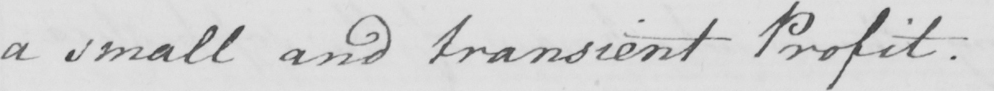What text is written in this handwritten line? a small and transient Profit . 